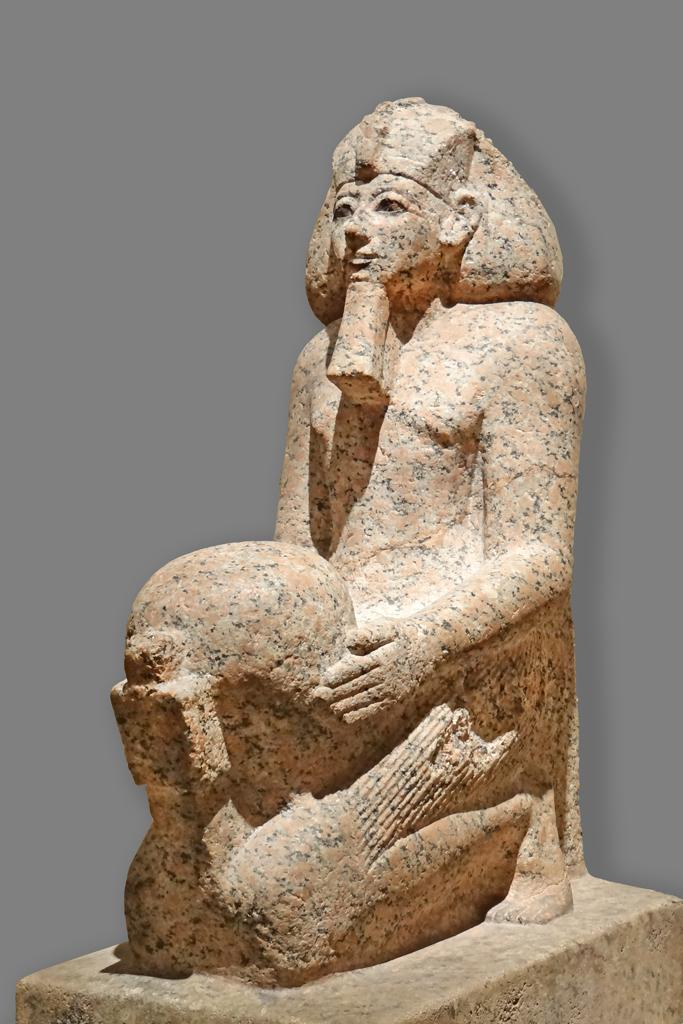What is the main subject in the image? There is a statue in the image. What can be seen in the background of the image? The background of the image is in a plain color. What type of rice is being served by the minister in the image? There is no minister or rice present in the image; it only features a statue and a plain background. 